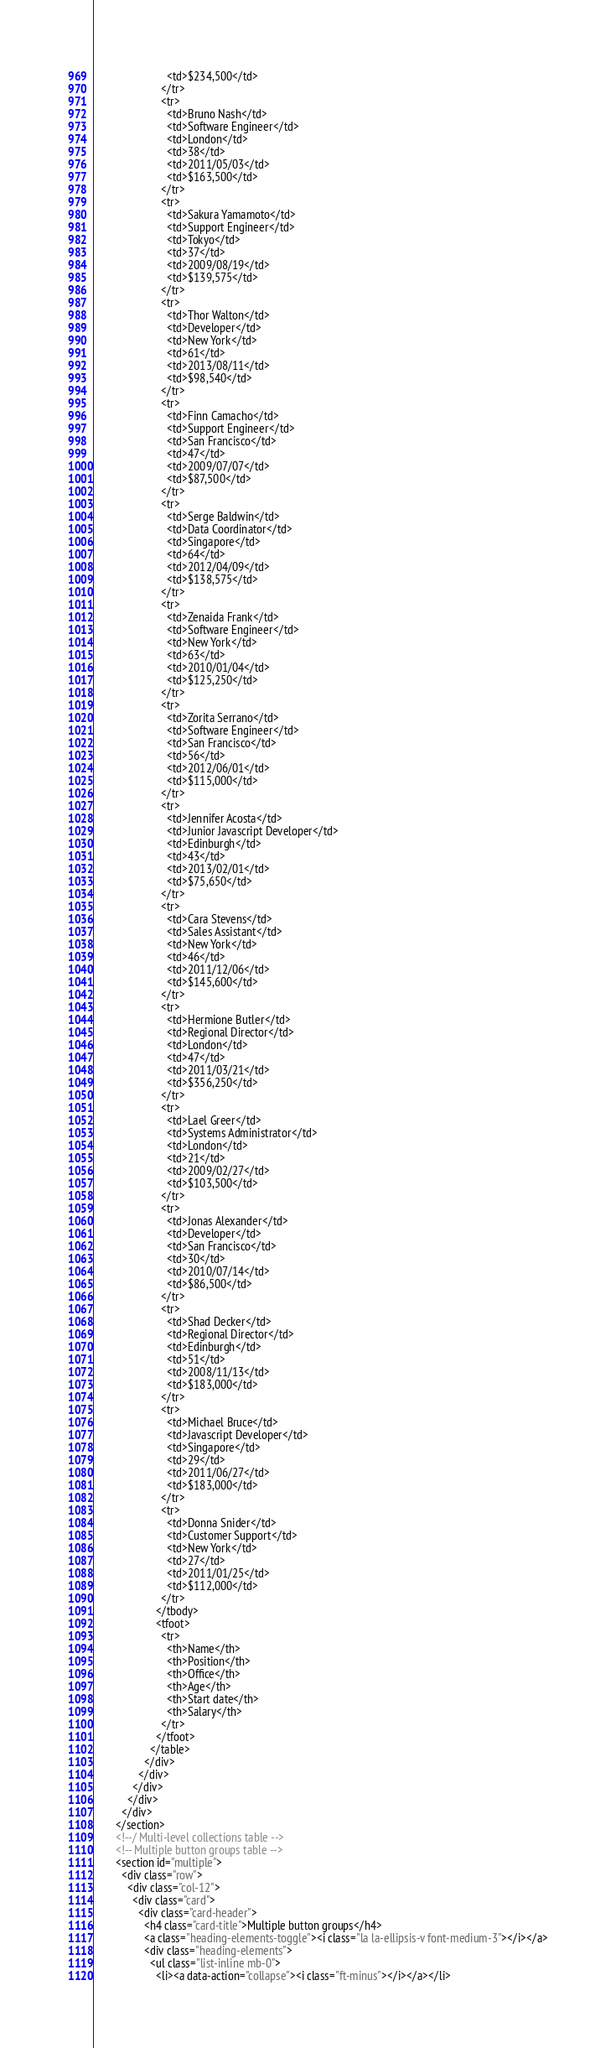<code> <loc_0><loc_0><loc_500><loc_500><_HTML_>                          <td>$234,500</td>
                        </tr>
                        <tr>
                          <td>Bruno Nash</td>
                          <td>Software Engineer</td>
                          <td>London</td>
                          <td>38</td>
                          <td>2011/05/03</td>
                          <td>$163,500</td>
                        </tr>
                        <tr>
                          <td>Sakura Yamamoto</td>
                          <td>Support Engineer</td>
                          <td>Tokyo</td>
                          <td>37</td>
                          <td>2009/08/19</td>
                          <td>$139,575</td>
                        </tr>
                        <tr>
                          <td>Thor Walton</td>
                          <td>Developer</td>
                          <td>New York</td>
                          <td>61</td>
                          <td>2013/08/11</td>
                          <td>$98,540</td>
                        </tr>
                        <tr>
                          <td>Finn Camacho</td>
                          <td>Support Engineer</td>
                          <td>San Francisco</td>
                          <td>47</td>
                          <td>2009/07/07</td>
                          <td>$87,500</td>
                        </tr>
                        <tr>
                          <td>Serge Baldwin</td>
                          <td>Data Coordinator</td>
                          <td>Singapore</td>
                          <td>64</td>
                          <td>2012/04/09</td>
                          <td>$138,575</td>
                        </tr>
                        <tr>
                          <td>Zenaida Frank</td>
                          <td>Software Engineer</td>
                          <td>New York</td>
                          <td>63</td>
                          <td>2010/01/04</td>
                          <td>$125,250</td>
                        </tr>
                        <tr>
                          <td>Zorita Serrano</td>
                          <td>Software Engineer</td>
                          <td>San Francisco</td>
                          <td>56</td>
                          <td>2012/06/01</td>
                          <td>$115,000</td>
                        </tr>
                        <tr>
                          <td>Jennifer Acosta</td>
                          <td>Junior Javascript Developer</td>
                          <td>Edinburgh</td>
                          <td>43</td>
                          <td>2013/02/01</td>
                          <td>$75,650</td>
                        </tr>
                        <tr>
                          <td>Cara Stevens</td>
                          <td>Sales Assistant</td>
                          <td>New York</td>
                          <td>46</td>
                          <td>2011/12/06</td>
                          <td>$145,600</td>
                        </tr>
                        <tr>
                          <td>Hermione Butler</td>
                          <td>Regional Director</td>
                          <td>London</td>
                          <td>47</td>
                          <td>2011/03/21</td>
                          <td>$356,250</td>
                        </tr>
                        <tr>
                          <td>Lael Greer</td>
                          <td>Systems Administrator</td>
                          <td>London</td>
                          <td>21</td>
                          <td>2009/02/27</td>
                          <td>$103,500</td>
                        </tr>
                        <tr>
                          <td>Jonas Alexander</td>
                          <td>Developer</td>
                          <td>San Francisco</td>
                          <td>30</td>
                          <td>2010/07/14</td>
                          <td>$86,500</td>
                        </tr>
                        <tr>
                          <td>Shad Decker</td>
                          <td>Regional Director</td>
                          <td>Edinburgh</td>
                          <td>51</td>
                          <td>2008/11/13</td>
                          <td>$183,000</td>
                        </tr>
                        <tr>
                          <td>Michael Bruce</td>
                          <td>Javascript Developer</td>
                          <td>Singapore</td>
                          <td>29</td>
                          <td>2011/06/27</td>
                          <td>$183,000</td>
                        </tr>
                        <tr>
                          <td>Donna Snider</td>
                          <td>Customer Support</td>
                          <td>New York</td>
                          <td>27</td>
                          <td>2011/01/25</td>
                          <td>$112,000</td>
                        </tr>
                      </tbody>
                      <tfoot>
                        <tr>
                          <th>Name</th>
                          <th>Position</th>
                          <th>Office</th>
                          <th>Age</th>
                          <th>Start date</th>
                          <th>Salary</th>
                        </tr>
                      </tfoot>
                    </table>
                  </div>
                </div>
              </div>
            </div>
          </div>
        </section>
        <!--/ Multi-level collections table -->
        <!-- Multiple button groups table -->
        <section id="multiple">
          <div class="row">
            <div class="col-12">
              <div class="card">
                <div class="card-header">
                  <h4 class="card-title">Multiple button groups</h4>
                  <a class="heading-elements-toggle"><i class="la la-ellipsis-v font-medium-3"></i></a>
                  <div class="heading-elements">
                    <ul class="list-inline mb-0">
                      <li><a data-action="collapse"><i class="ft-minus"></i></a></li></code> 